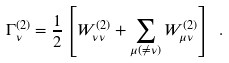<formula> <loc_0><loc_0><loc_500><loc_500>\Gamma ^ { ( 2 ) } _ { \nu } = \frac { 1 } { 2 } \left [ W ^ { ( 2 ) } _ { \nu \nu } + \sum _ { \mu ( \ne \nu ) } W ^ { ( 2 ) } _ { \mu \nu } \right ] \ .</formula> 